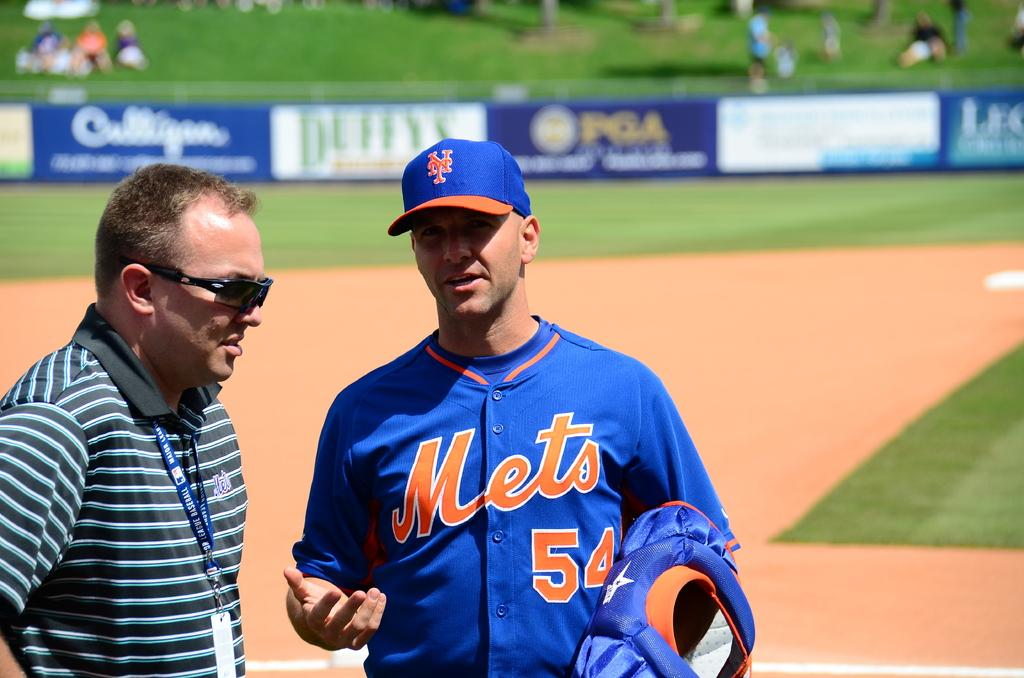Provide a one-sentence caption for the provided image. Player number 54 for the Mets talks with a man in sunglasses. 